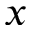Convert formula to latex. <formula><loc_0><loc_0><loc_500><loc_500>x</formula> 